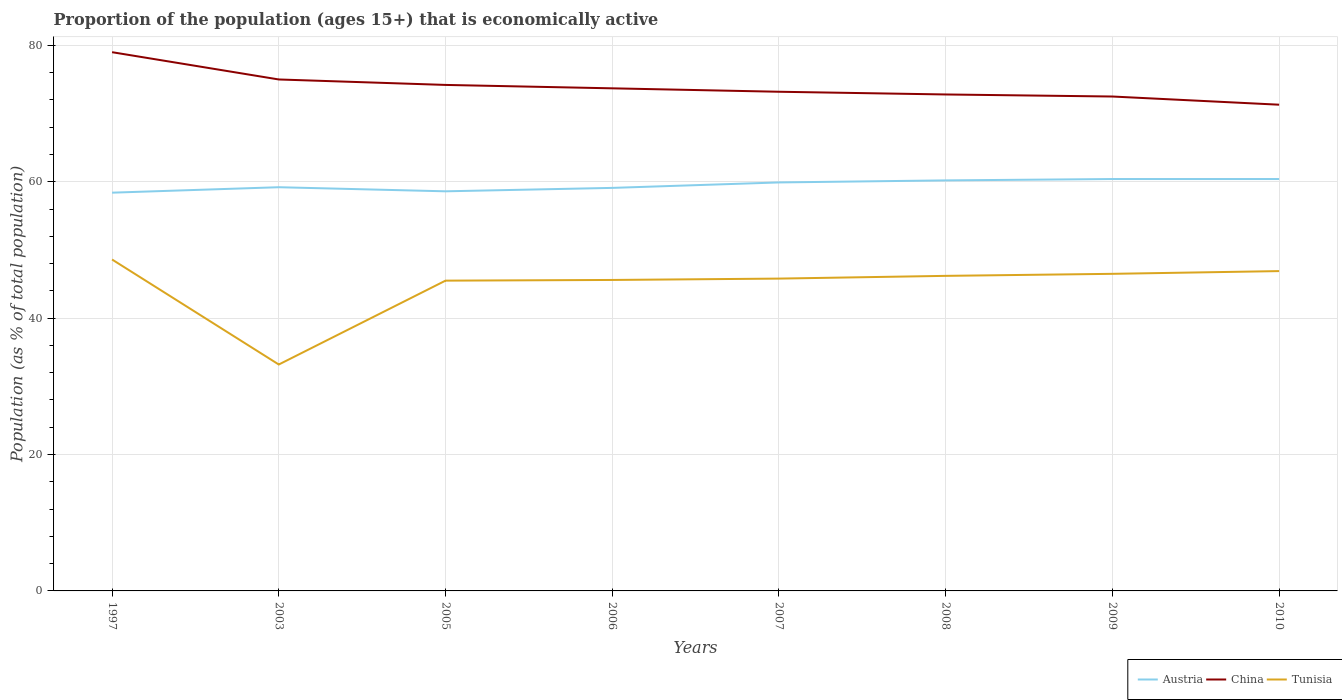Is the number of lines equal to the number of legend labels?
Provide a succinct answer. Yes. Across all years, what is the maximum proportion of the population that is economically active in Tunisia?
Your answer should be very brief. 33.2. What is the difference between the highest and the second highest proportion of the population that is economically active in Austria?
Your answer should be very brief. 2. Is the proportion of the population that is economically active in Tunisia strictly greater than the proportion of the population that is economically active in China over the years?
Your answer should be very brief. Yes. How many lines are there?
Make the answer very short. 3. Are the values on the major ticks of Y-axis written in scientific E-notation?
Offer a terse response. No. Where does the legend appear in the graph?
Make the answer very short. Bottom right. How many legend labels are there?
Give a very brief answer. 3. How are the legend labels stacked?
Give a very brief answer. Horizontal. What is the title of the graph?
Your answer should be very brief. Proportion of the population (ages 15+) that is economically active. Does "Hong Kong" appear as one of the legend labels in the graph?
Keep it short and to the point. No. What is the label or title of the X-axis?
Ensure brevity in your answer.  Years. What is the label or title of the Y-axis?
Offer a very short reply. Population (as % of total population). What is the Population (as % of total population) of Austria in 1997?
Provide a succinct answer. 58.4. What is the Population (as % of total population) in China in 1997?
Your answer should be very brief. 79. What is the Population (as % of total population) of Tunisia in 1997?
Ensure brevity in your answer.  48.6. What is the Population (as % of total population) of Austria in 2003?
Keep it short and to the point. 59.2. What is the Population (as % of total population) in Tunisia in 2003?
Your answer should be very brief. 33.2. What is the Population (as % of total population) of Austria in 2005?
Give a very brief answer. 58.6. What is the Population (as % of total population) of China in 2005?
Your response must be concise. 74.2. What is the Population (as % of total population) in Tunisia in 2005?
Offer a terse response. 45.5. What is the Population (as % of total population) in Austria in 2006?
Offer a very short reply. 59.1. What is the Population (as % of total population) of China in 2006?
Keep it short and to the point. 73.7. What is the Population (as % of total population) of Tunisia in 2006?
Offer a very short reply. 45.6. What is the Population (as % of total population) of Austria in 2007?
Your response must be concise. 59.9. What is the Population (as % of total population) in China in 2007?
Give a very brief answer. 73.2. What is the Population (as % of total population) in Tunisia in 2007?
Make the answer very short. 45.8. What is the Population (as % of total population) in Austria in 2008?
Offer a terse response. 60.2. What is the Population (as % of total population) of China in 2008?
Offer a very short reply. 72.8. What is the Population (as % of total population) in Tunisia in 2008?
Ensure brevity in your answer.  46.2. What is the Population (as % of total population) in Austria in 2009?
Offer a very short reply. 60.4. What is the Population (as % of total population) of China in 2009?
Give a very brief answer. 72.5. What is the Population (as % of total population) of Tunisia in 2009?
Give a very brief answer. 46.5. What is the Population (as % of total population) of Austria in 2010?
Your response must be concise. 60.4. What is the Population (as % of total population) in China in 2010?
Keep it short and to the point. 71.3. What is the Population (as % of total population) of Tunisia in 2010?
Your answer should be very brief. 46.9. Across all years, what is the maximum Population (as % of total population) in Austria?
Give a very brief answer. 60.4. Across all years, what is the maximum Population (as % of total population) in China?
Your answer should be compact. 79. Across all years, what is the maximum Population (as % of total population) in Tunisia?
Give a very brief answer. 48.6. Across all years, what is the minimum Population (as % of total population) of Austria?
Give a very brief answer. 58.4. Across all years, what is the minimum Population (as % of total population) in China?
Make the answer very short. 71.3. Across all years, what is the minimum Population (as % of total population) of Tunisia?
Ensure brevity in your answer.  33.2. What is the total Population (as % of total population) in Austria in the graph?
Keep it short and to the point. 476.2. What is the total Population (as % of total population) in China in the graph?
Keep it short and to the point. 591.7. What is the total Population (as % of total population) in Tunisia in the graph?
Provide a succinct answer. 358.3. What is the difference between the Population (as % of total population) of Austria in 1997 and that in 2003?
Ensure brevity in your answer.  -0.8. What is the difference between the Population (as % of total population) in China in 1997 and that in 2003?
Make the answer very short. 4. What is the difference between the Population (as % of total population) in China in 1997 and that in 2005?
Offer a very short reply. 4.8. What is the difference between the Population (as % of total population) of Austria in 1997 and that in 2006?
Keep it short and to the point. -0.7. What is the difference between the Population (as % of total population) of Tunisia in 1997 and that in 2006?
Provide a short and direct response. 3. What is the difference between the Population (as % of total population) in Austria in 1997 and that in 2007?
Your response must be concise. -1.5. What is the difference between the Population (as % of total population) of Tunisia in 1997 and that in 2007?
Provide a short and direct response. 2.8. What is the difference between the Population (as % of total population) of Austria in 1997 and that in 2008?
Make the answer very short. -1.8. What is the difference between the Population (as % of total population) in Austria in 1997 and that in 2009?
Offer a terse response. -2. What is the difference between the Population (as % of total population) in Tunisia in 1997 and that in 2009?
Keep it short and to the point. 2.1. What is the difference between the Population (as % of total population) of Austria in 1997 and that in 2010?
Provide a succinct answer. -2. What is the difference between the Population (as % of total population) in China in 1997 and that in 2010?
Your answer should be compact. 7.7. What is the difference between the Population (as % of total population) in Tunisia in 2003 and that in 2005?
Your answer should be very brief. -12.3. What is the difference between the Population (as % of total population) of China in 2003 and that in 2006?
Give a very brief answer. 1.3. What is the difference between the Population (as % of total population) in China in 2003 and that in 2007?
Give a very brief answer. 1.8. What is the difference between the Population (as % of total population) in China in 2003 and that in 2008?
Offer a terse response. 2.2. What is the difference between the Population (as % of total population) in Tunisia in 2003 and that in 2008?
Your answer should be compact. -13. What is the difference between the Population (as % of total population) in Tunisia in 2003 and that in 2010?
Provide a succinct answer. -13.7. What is the difference between the Population (as % of total population) in Tunisia in 2005 and that in 2006?
Provide a succinct answer. -0.1. What is the difference between the Population (as % of total population) of China in 2005 and that in 2007?
Ensure brevity in your answer.  1. What is the difference between the Population (as % of total population) of Tunisia in 2005 and that in 2007?
Make the answer very short. -0.3. What is the difference between the Population (as % of total population) in Austria in 2005 and that in 2008?
Provide a short and direct response. -1.6. What is the difference between the Population (as % of total population) in China in 2005 and that in 2008?
Offer a terse response. 1.4. What is the difference between the Population (as % of total population) in Tunisia in 2005 and that in 2009?
Provide a succinct answer. -1. What is the difference between the Population (as % of total population) of China in 2005 and that in 2010?
Provide a succinct answer. 2.9. What is the difference between the Population (as % of total population) in Tunisia in 2005 and that in 2010?
Provide a succinct answer. -1.4. What is the difference between the Population (as % of total population) of China in 2006 and that in 2007?
Provide a short and direct response. 0.5. What is the difference between the Population (as % of total population) of China in 2006 and that in 2008?
Your response must be concise. 0.9. What is the difference between the Population (as % of total population) of Tunisia in 2006 and that in 2008?
Provide a succinct answer. -0.6. What is the difference between the Population (as % of total population) of Austria in 2006 and that in 2009?
Offer a very short reply. -1.3. What is the difference between the Population (as % of total population) in Tunisia in 2006 and that in 2009?
Provide a short and direct response. -0.9. What is the difference between the Population (as % of total population) in Austria in 2006 and that in 2010?
Make the answer very short. -1.3. What is the difference between the Population (as % of total population) in China in 2006 and that in 2010?
Give a very brief answer. 2.4. What is the difference between the Population (as % of total population) of China in 2007 and that in 2008?
Give a very brief answer. 0.4. What is the difference between the Population (as % of total population) of Austria in 2007 and that in 2009?
Your answer should be compact. -0.5. What is the difference between the Population (as % of total population) of Austria in 2007 and that in 2010?
Provide a succinct answer. -0.5. What is the difference between the Population (as % of total population) in China in 2007 and that in 2010?
Keep it short and to the point. 1.9. What is the difference between the Population (as % of total population) in China in 2008 and that in 2009?
Give a very brief answer. 0.3. What is the difference between the Population (as % of total population) in Austria in 2008 and that in 2010?
Your response must be concise. -0.2. What is the difference between the Population (as % of total population) in Austria in 2009 and that in 2010?
Provide a short and direct response. 0. What is the difference between the Population (as % of total population) of Tunisia in 2009 and that in 2010?
Give a very brief answer. -0.4. What is the difference between the Population (as % of total population) of Austria in 1997 and the Population (as % of total population) of China in 2003?
Your answer should be compact. -16.6. What is the difference between the Population (as % of total population) of Austria in 1997 and the Population (as % of total population) of Tunisia in 2003?
Provide a succinct answer. 25.2. What is the difference between the Population (as % of total population) of China in 1997 and the Population (as % of total population) of Tunisia in 2003?
Your answer should be very brief. 45.8. What is the difference between the Population (as % of total population) in Austria in 1997 and the Population (as % of total population) in China in 2005?
Your answer should be compact. -15.8. What is the difference between the Population (as % of total population) in Austria in 1997 and the Population (as % of total population) in Tunisia in 2005?
Give a very brief answer. 12.9. What is the difference between the Population (as % of total population) in China in 1997 and the Population (as % of total population) in Tunisia in 2005?
Your response must be concise. 33.5. What is the difference between the Population (as % of total population) of Austria in 1997 and the Population (as % of total population) of China in 2006?
Your response must be concise. -15.3. What is the difference between the Population (as % of total population) in Austria in 1997 and the Population (as % of total population) in Tunisia in 2006?
Your response must be concise. 12.8. What is the difference between the Population (as % of total population) of China in 1997 and the Population (as % of total population) of Tunisia in 2006?
Your response must be concise. 33.4. What is the difference between the Population (as % of total population) of Austria in 1997 and the Population (as % of total population) of China in 2007?
Your answer should be compact. -14.8. What is the difference between the Population (as % of total population) in Austria in 1997 and the Population (as % of total population) in Tunisia in 2007?
Provide a short and direct response. 12.6. What is the difference between the Population (as % of total population) in China in 1997 and the Population (as % of total population) in Tunisia in 2007?
Offer a very short reply. 33.2. What is the difference between the Population (as % of total population) of Austria in 1997 and the Population (as % of total population) of China in 2008?
Offer a very short reply. -14.4. What is the difference between the Population (as % of total population) of China in 1997 and the Population (as % of total population) of Tunisia in 2008?
Give a very brief answer. 32.8. What is the difference between the Population (as % of total population) in Austria in 1997 and the Population (as % of total population) in China in 2009?
Offer a terse response. -14.1. What is the difference between the Population (as % of total population) of China in 1997 and the Population (as % of total population) of Tunisia in 2009?
Provide a short and direct response. 32.5. What is the difference between the Population (as % of total population) of Austria in 1997 and the Population (as % of total population) of Tunisia in 2010?
Provide a succinct answer. 11.5. What is the difference between the Population (as % of total population) of China in 1997 and the Population (as % of total population) of Tunisia in 2010?
Offer a terse response. 32.1. What is the difference between the Population (as % of total population) of Austria in 2003 and the Population (as % of total population) of Tunisia in 2005?
Offer a terse response. 13.7. What is the difference between the Population (as % of total population) in China in 2003 and the Population (as % of total population) in Tunisia in 2005?
Make the answer very short. 29.5. What is the difference between the Population (as % of total population) of Austria in 2003 and the Population (as % of total population) of Tunisia in 2006?
Your response must be concise. 13.6. What is the difference between the Population (as % of total population) of China in 2003 and the Population (as % of total population) of Tunisia in 2006?
Offer a terse response. 29.4. What is the difference between the Population (as % of total population) of Austria in 2003 and the Population (as % of total population) of Tunisia in 2007?
Keep it short and to the point. 13.4. What is the difference between the Population (as % of total population) in China in 2003 and the Population (as % of total population) in Tunisia in 2007?
Your answer should be compact. 29.2. What is the difference between the Population (as % of total population) in Austria in 2003 and the Population (as % of total population) in China in 2008?
Keep it short and to the point. -13.6. What is the difference between the Population (as % of total population) of China in 2003 and the Population (as % of total population) of Tunisia in 2008?
Your answer should be very brief. 28.8. What is the difference between the Population (as % of total population) of Austria in 2003 and the Population (as % of total population) of China in 2009?
Give a very brief answer. -13.3. What is the difference between the Population (as % of total population) in China in 2003 and the Population (as % of total population) in Tunisia in 2010?
Provide a short and direct response. 28.1. What is the difference between the Population (as % of total population) in Austria in 2005 and the Population (as % of total population) in China in 2006?
Offer a very short reply. -15.1. What is the difference between the Population (as % of total population) in China in 2005 and the Population (as % of total population) in Tunisia in 2006?
Offer a very short reply. 28.6. What is the difference between the Population (as % of total population) of Austria in 2005 and the Population (as % of total population) of China in 2007?
Provide a succinct answer. -14.6. What is the difference between the Population (as % of total population) of China in 2005 and the Population (as % of total population) of Tunisia in 2007?
Provide a succinct answer. 28.4. What is the difference between the Population (as % of total population) in China in 2005 and the Population (as % of total population) in Tunisia in 2008?
Offer a very short reply. 28. What is the difference between the Population (as % of total population) of China in 2005 and the Population (as % of total population) of Tunisia in 2009?
Provide a succinct answer. 27.7. What is the difference between the Population (as % of total population) in Austria in 2005 and the Population (as % of total population) in China in 2010?
Your answer should be compact. -12.7. What is the difference between the Population (as % of total population) of China in 2005 and the Population (as % of total population) of Tunisia in 2010?
Ensure brevity in your answer.  27.3. What is the difference between the Population (as % of total population) of Austria in 2006 and the Population (as % of total population) of China in 2007?
Offer a terse response. -14.1. What is the difference between the Population (as % of total population) of Austria in 2006 and the Population (as % of total population) of Tunisia in 2007?
Provide a short and direct response. 13.3. What is the difference between the Population (as % of total population) in China in 2006 and the Population (as % of total population) in Tunisia in 2007?
Provide a short and direct response. 27.9. What is the difference between the Population (as % of total population) in Austria in 2006 and the Population (as % of total population) in China in 2008?
Your response must be concise. -13.7. What is the difference between the Population (as % of total population) in Austria in 2006 and the Population (as % of total population) in Tunisia in 2008?
Ensure brevity in your answer.  12.9. What is the difference between the Population (as % of total population) in China in 2006 and the Population (as % of total population) in Tunisia in 2008?
Make the answer very short. 27.5. What is the difference between the Population (as % of total population) in China in 2006 and the Population (as % of total population) in Tunisia in 2009?
Provide a succinct answer. 27.2. What is the difference between the Population (as % of total population) in Austria in 2006 and the Population (as % of total population) in China in 2010?
Keep it short and to the point. -12.2. What is the difference between the Population (as % of total population) of Austria in 2006 and the Population (as % of total population) of Tunisia in 2010?
Your response must be concise. 12.2. What is the difference between the Population (as % of total population) of China in 2006 and the Population (as % of total population) of Tunisia in 2010?
Your answer should be compact. 26.8. What is the difference between the Population (as % of total population) of Austria in 2007 and the Population (as % of total population) of China in 2008?
Give a very brief answer. -12.9. What is the difference between the Population (as % of total population) in Austria in 2007 and the Population (as % of total population) in China in 2009?
Your response must be concise. -12.6. What is the difference between the Population (as % of total population) in China in 2007 and the Population (as % of total population) in Tunisia in 2009?
Offer a terse response. 26.7. What is the difference between the Population (as % of total population) of Austria in 2007 and the Population (as % of total population) of China in 2010?
Give a very brief answer. -11.4. What is the difference between the Population (as % of total population) of Austria in 2007 and the Population (as % of total population) of Tunisia in 2010?
Provide a short and direct response. 13. What is the difference between the Population (as % of total population) of China in 2007 and the Population (as % of total population) of Tunisia in 2010?
Give a very brief answer. 26.3. What is the difference between the Population (as % of total population) of Austria in 2008 and the Population (as % of total population) of China in 2009?
Provide a short and direct response. -12.3. What is the difference between the Population (as % of total population) of China in 2008 and the Population (as % of total population) of Tunisia in 2009?
Your answer should be very brief. 26.3. What is the difference between the Population (as % of total population) in Austria in 2008 and the Population (as % of total population) in Tunisia in 2010?
Your answer should be very brief. 13.3. What is the difference between the Population (as % of total population) in China in 2008 and the Population (as % of total population) in Tunisia in 2010?
Provide a succinct answer. 25.9. What is the difference between the Population (as % of total population) of Austria in 2009 and the Population (as % of total population) of China in 2010?
Ensure brevity in your answer.  -10.9. What is the difference between the Population (as % of total population) in China in 2009 and the Population (as % of total population) in Tunisia in 2010?
Make the answer very short. 25.6. What is the average Population (as % of total population) of Austria per year?
Your answer should be compact. 59.52. What is the average Population (as % of total population) of China per year?
Your answer should be compact. 73.96. What is the average Population (as % of total population) of Tunisia per year?
Ensure brevity in your answer.  44.79. In the year 1997, what is the difference between the Population (as % of total population) of Austria and Population (as % of total population) of China?
Your response must be concise. -20.6. In the year 1997, what is the difference between the Population (as % of total population) of China and Population (as % of total population) of Tunisia?
Keep it short and to the point. 30.4. In the year 2003, what is the difference between the Population (as % of total population) of Austria and Population (as % of total population) of China?
Your response must be concise. -15.8. In the year 2003, what is the difference between the Population (as % of total population) of China and Population (as % of total population) of Tunisia?
Give a very brief answer. 41.8. In the year 2005, what is the difference between the Population (as % of total population) in Austria and Population (as % of total population) in China?
Give a very brief answer. -15.6. In the year 2005, what is the difference between the Population (as % of total population) in Austria and Population (as % of total population) in Tunisia?
Ensure brevity in your answer.  13.1. In the year 2005, what is the difference between the Population (as % of total population) of China and Population (as % of total population) of Tunisia?
Offer a terse response. 28.7. In the year 2006, what is the difference between the Population (as % of total population) of Austria and Population (as % of total population) of China?
Provide a succinct answer. -14.6. In the year 2006, what is the difference between the Population (as % of total population) in Austria and Population (as % of total population) in Tunisia?
Offer a very short reply. 13.5. In the year 2006, what is the difference between the Population (as % of total population) of China and Population (as % of total population) of Tunisia?
Your answer should be compact. 28.1. In the year 2007, what is the difference between the Population (as % of total population) in Austria and Population (as % of total population) in China?
Provide a short and direct response. -13.3. In the year 2007, what is the difference between the Population (as % of total population) in Austria and Population (as % of total population) in Tunisia?
Make the answer very short. 14.1. In the year 2007, what is the difference between the Population (as % of total population) of China and Population (as % of total population) of Tunisia?
Provide a short and direct response. 27.4. In the year 2008, what is the difference between the Population (as % of total population) in China and Population (as % of total population) in Tunisia?
Provide a short and direct response. 26.6. In the year 2009, what is the difference between the Population (as % of total population) in China and Population (as % of total population) in Tunisia?
Your answer should be very brief. 26. In the year 2010, what is the difference between the Population (as % of total population) in China and Population (as % of total population) in Tunisia?
Keep it short and to the point. 24.4. What is the ratio of the Population (as % of total population) of Austria in 1997 to that in 2003?
Give a very brief answer. 0.99. What is the ratio of the Population (as % of total population) in China in 1997 to that in 2003?
Give a very brief answer. 1.05. What is the ratio of the Population (as % of total population) in Tunisia in 1997 to that in 2003?
Keep it short and to the point. 1.46. What is the ratio of the Population (as % of total population) of Austria in 1997 to that in 2005?
Your answer should be very brief. 1. What is the ratio of the Population (as % of total population) in China in 1997 to that in 2005?
Your response must be concise. 1.06. What is the ratio of the Population (as % of total population) of Tunisia in 1997 to that in 2005?
Provide a succinct answer. 1.07. What is the ratio of the Population (as % of total population) of China in 1997 to that in 2006?
Offer a very short reply. 1.07. What is the ratio of the Population (as % of total population) of Tunisia in 1997 to that in 2006?
Provide a short and direct response. 1.07. What is the ratio of the Population (as % of total population) of China in 1997 to that in 2007?
Give a very brief answer. 1.08. What is the ratio of the Population (as % of total population) in Tunisia in 1997 to that in 2007?
Make the answer very short. 1.06. What is the ratio of the Population (as % of total population) in Austria in 1997 to that in 2008?
Ensure brevity in your answer.  0.97. What is the ratio of the Population (as % of total population) of China in 1997 to that in 2008?
Keep it short and to the point. 1.09. What is the ratio of the Population (as % of total population) in Tunisia in 1997 to that in 2008?
Ensure brevity in your answer.  1.05. What is the ratio of the Population (as % of total population) of Austria in 1997 to that in 2009?
Offer a terse response. 0.97. What is the ratio of the Population (as % of total population) in China in 1997 to that in 2009?
Provide a short and direct response. 1.09. What is the ratio of the Population (as % of total population) of Tunisia in 1997 to that in 2009?
Your answer should be compact. 1.05. What is the ratio of the Population (as % of total population) in Austria in 1997 to that in 2010?
Your answer should be compact. 0.97. What is the ratio of the Population (as % of total population) in China in 1997 to that in 2010?
Provide a short and direct response. 1.11. What is the ratio of the Population (as % of total population) in Tunisia in 1997 to that in 2010?
Provide a short and direct response. 1.04. What is the ratio of the Population (as % of total population) of Austria in 2003 to that in 2005?
Your answer should be very brief. 1.01. What is the ratio of the Population (as % of total population) in China in 2003 to that in 2005?
Your answer should be very brief. 1.01. What is the ratio of the Population (as % of total population) of Tunisia in 2003 to that in 2005?
Make the answer very short. 0.73. What is the ratio of the Population (as % of total population) in Austria in 2003 to that in 2006?
Your answer should be very brief. 1. What is the ratio of the Population (as % of total population) of China in 2003 to that in 2006?
Offer a very short reply. 1.02. What is the ratio of the Population (as % of total population) in Tunisia in 2003 to that in 2006?
Provide a short and direct response. 0.73. What is the ratio of the Population (as % of total population) of Austria in 2003 to that in 2007?
Provide a short and direct response. 0.99. What is the ratio of the Population (as % of total population) in China in 2003 to that in 2007?
Provide a succinct answer. 1.02. What is the ratio of the Population (as % of total population) of Tunisia in 2003 to that in 2007?
Your answer should be very brief. 0.72. What is the ratio of the Population (as % of total population) of Austria in 2003 to that in 2008?
Provide a succinct answer. 0.98. What is the ratio of the Population (as % of total population) in China in 2003 to that in 2008?
Give a very brief answer. 1.03. What is the ratio of the Population (as % of total population) of Tunisia in 2003 to that in 2008?
Ensure brevity in your answer.  0.72. What is the ratio of the Population (as % of total population) in Austria in 2003 to that in 2009?
Keep it short and to the point. 0.98. What is the ratio of the Population (as % of total population) in China in 2003 to that in 2009?
Your answer should be compact. 1.03. What is the ratio of the Population (as % of total population) in Tunisia in 2003 to that in 2009?
Ensure brevity in your answer.  0.71. What is the ratio of the Population (as % of total population) of Austria in 2003 to that in 2010?
Give a very brief answer. 0.98. What is the ratio of the Population (as % of total population) of China in 2003 to that in 2010?
Provide a short and direct response. 1.05. What is the ratio of the Population (as % of total population) in Tunisia in 2003 to that in 2010?
Provide a short and direct response. 0.71. What is the ratio of the Population (as % of total population) of Austria in 2005 to that in 2006?
Offer a very short reply. 0.99. What is the ratio of the Population (as % of total population) in China in 2005 to that in 2006?
Provide a short and direct response. 1.01. What is the ratio of the Population (as % of total population) of Austria in 2005 to that in 2007?
Your answer should be compact. 0.98. What is the ratio of the Population (as % of total population) of China in 2005 to that in 2007?
Provide a short and direct response. 1.01. What is the ratio of the Population (as % of total population) in Tunisia in 2005 to that in 2007?
Your answer should be very brief. 0.99. What is the ratio of the Population (as % of total population) of Austria in 2005 to that in 2008?
Offer a very short reply. 0.97. What is the ratio of the Population (as % of total population) of China in 2005 to that in 2008?
Offer a very short reply. 1.02. What is the ratio of the Population (as % of total population) of Tunisia in 2005 to that in 2008?
Keep it short and to the point. 0.98. What is the ratio of the Population (as % of total population) in Austria in 2005 to that in 2009?
Your answer should be compact. 0.97. What is the ratio of the Population (as % of total population) in China in 2005 to that in 2009?
Provide a succinct answer. 1.02. What is the ratio of the Population (as % of total population) in Tunisia in 2005 to that in 2009?
Ensure brevity in your answer.  0.98. What is the ratio of the Population (as % of total population) in Austria in 2005 to that in 2010?
Provide a succinct answer. 0.97. What is the ratio of the Population (as % of total population) of China in 2005 to that in 2010?
Give a very brief answer. 1.04. What is the ratio of the Population (as % of total population) in Tunisia in 2005 to that in 2010?
Offer a very short reply. 0.97. What is the ratio of the Population (as % of total population) in Austria in 2006 to that in 2007?
Your answer should be compact. 0.99. What is the ratio of the Population (as % of total population) in China in 2006 to that in 2007?
Your response must be concise. 1.01. What is the ratio of the Population (as % of total population) of Tunisia in 2006 to that in 2007?
Offer a very short reply. 1. What is the ratio of the Population (as % of total population) in Austria in 2006 to that in 2008?
Keep it short and to the point. 0.98. What is the ratio of the Population (as % of total population) in China in 2006 to that in 2008?
Provide a short and direct response. 1.01. What is the ratio of the Population (as % of total population) in Tunisia in 2006 to that in 2008?
Your answer should be compact. 0.99. What is the ratio of the Population (as % of total population) of Austria in 2006 to that in 2009?
Give a very brief answer. 0.98. What is the ratio of the Population (as % of total population) in China in 2006 to that in 2009?
Offer a terse response. 1.02. What is the ratio of the Population (as % of total population) of Tunisia in 2006 to that in 2009?
Offer a very short reply. 0.98. What is the ratio of the Population (as % of total population) in Austria in 2006 to that in 2010?
Provide a short and direct response. 0.98. What is the ratio of the Population (as % of total population) in China in 2006 to that in 2010?
Provide a short and direct response. 1.03. What is the ratio of the Population (as % of total population) in Tunisia in 2006 to that in 2010?
Your response must be concise. 0.97. What is the ratio of the Population (as % of total population) in China in 2007 to that in 2009?
Your answer should be very brief. 1.01. What is the ratio of the Population (as % of total population) in Tunisia in 2007 to that in 2009?
Offer a terse response. 0.98. What is the ratio of the Population (as % of total population) of China in 2007 to that in 2010?
Give a very brief answer. 1.03. What is the ratio of the Population (as % of total population) in Tunisia in 2007 to that in 2010?
Offer a terse response. 0.98. What is the ratio of the Population (as % of total population) in Austria in 2008 to that in 2009?
Offer a very short reply. 1. What is the ratio of the Population (as % of total population) of Tunisia in 2008 to that in 2010?
Your answer should be very brief. 0.99. What is the ratio of the Population (as % of total population) in China in 2009 to that in 2010?
Offer a terse response. 1.02. What is the difference between the highest and the second highest Population (as % of total population) of Tunisia?
Make the answer very short. 1.7. 